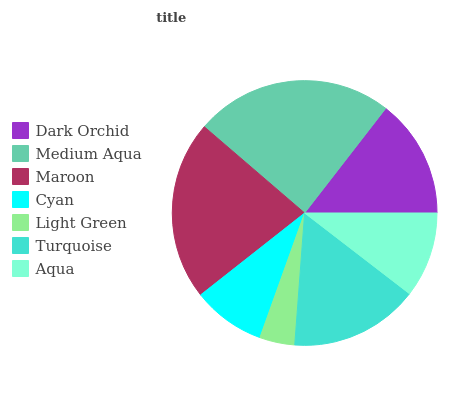Is Light Green the minimum?
Answer yes or no. Yes. Is Medium Aqua the maximum?
Answer yes or no. Yes. Is Maroon the minimum?
Answer yes or no. No. Is Maroon the maximum?
Answer yes or no. No. Is Medium Aqua greater than Maroon?
Answer yes or no. Yes. Is Maroon less than Medium Aqua?
Answer yes or no. Yes. Is Maroon greater than Medium Aqua?
Answer yes or no. No. Is Medium Aqua less than Maroon?
Answer yes or no. No. Is Dark Orchid the high median?
Answer yes or no. Yes. Is Dark Orchid the low median?
Answer yes or no. Yes. Is Turquoise the high median?
Answer yes or no. No. Is Turquoise the low median?
Answer yes or no. No. 